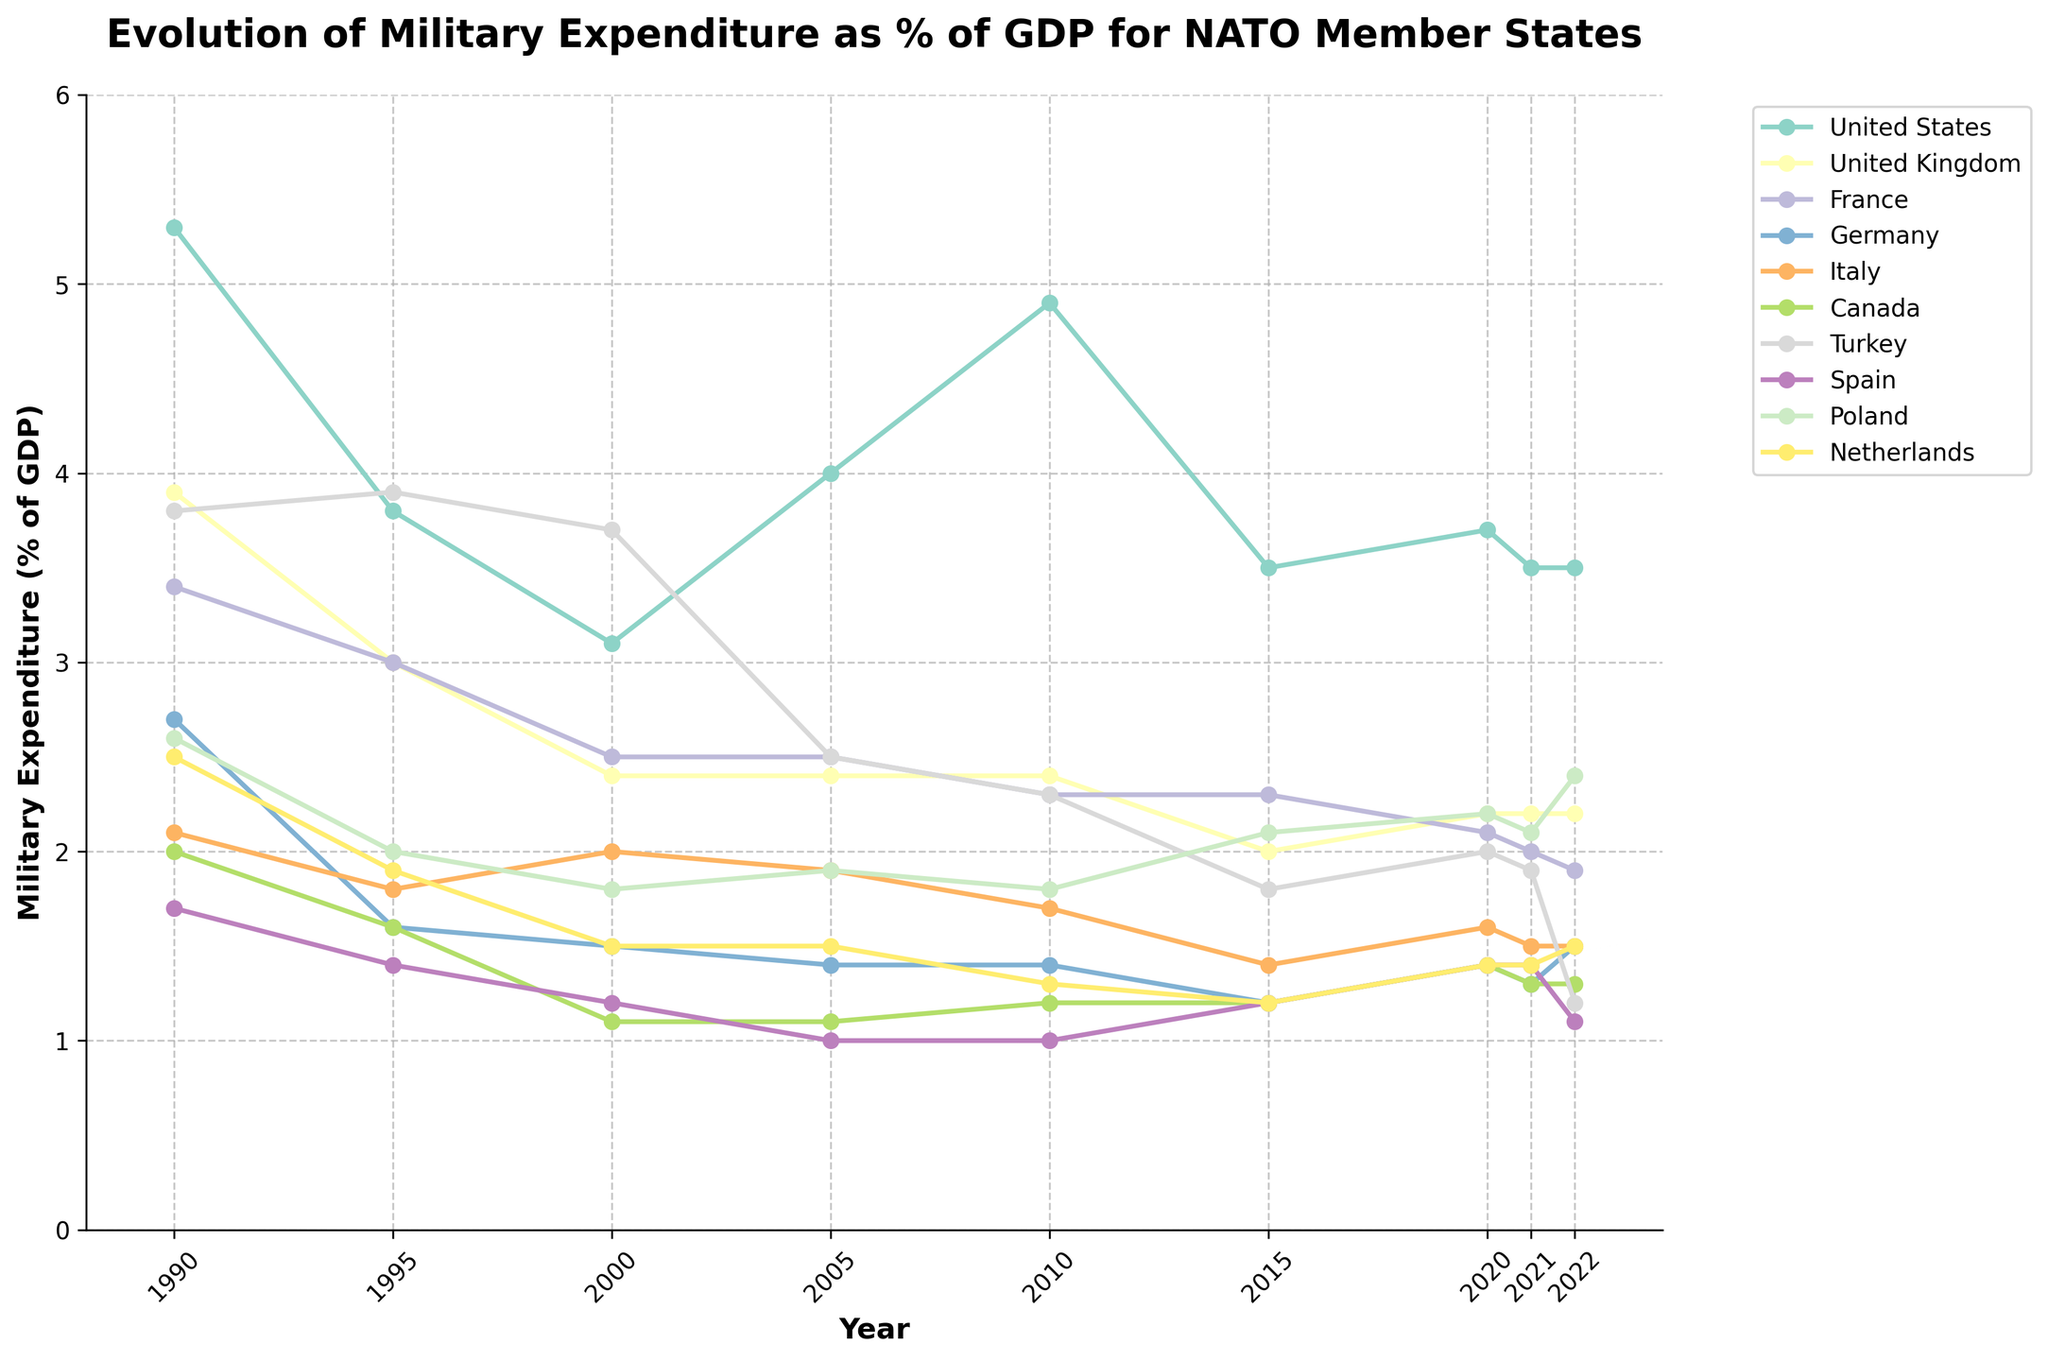Which country shows the highest military expenditure as a percentage of GDP in 1990? The figure shows the military expenditure percentages clearly. The highest line in 1990 corresponds to the United States, which is around 5.3%.
Answer: United States Which two countries have the most significant drop in military expenditure as a percentage of GDP from 1990 to 2000? By comparing the lines from 1990 to 2000, the United States drops from 5.3% to 3.1% and the United Kingdom from 3.9% to 2.4%, indicating significant drops.
Answer: United States, United Kingdom Which country’s military expenditure as a percentage of GDP remained relatively stable from 1990 to 2022? By observing the lines, Turkey's military expenditure fluctuated slightly but stayed around 3.8% initially and ends at 1.2% in 2022. Thus, it remained relatively stable without drastic changes compared to others.
Answer: Turkey In what year did the United States see the highest military expenditure as a percentage of GDP, according to the graph? The highest point along the United States' line on the graph is in 1990, where it reaches 5.3%.
Answer: 1990 Which country exhibited the lowest military expenditure as a percentage of GDP in 2005? Looking at 2005, Spain is at the lowest with an expenditure around 1.0% as visually represented on the graph.
Answer: Spain Between Germany and Italy, which country saw a greater decline in military expenditure as a percentage of GDP from 1990 to 2022? Germany's military expenditure went from 2.7% to 1.5%, and Italy's from 2.1% to 1.5%. By comparing the differences (Germany: 2.7% - 1.5% = 1.2%, Italy: 2.1% - 1.5% = 0.6%), Germany saw a greater decline.
Answer: Germany What is the average military expenditure as a percentage of GDP for Canada from 1990 to 2022? Collect the data points for Canada (2.0, 1.6, 1.1, 1.1, 1.2, 1.2, 1.4, 1.3, 1.3), sum them (12.2), then divide by the number of values (9). The average is approximately 1.36%.
Answer: 1.36% Which country has a consistent upward trend in military expenditure as a percentage of GDP from 2000 to 2022? Poland shows a consistently increasing trend from 1.8% in 2000 to 2.4% in 2022. The line for Poland rises steadily over these years.
Answer: Poland Which two countries have nearly overlapping military expenditure percentages in 2022? In 2022, the lines for Spain and France nearly overlap, both are around 1.1% to 1.9%, indicating similar expenditures.
Answer: Spain, France 